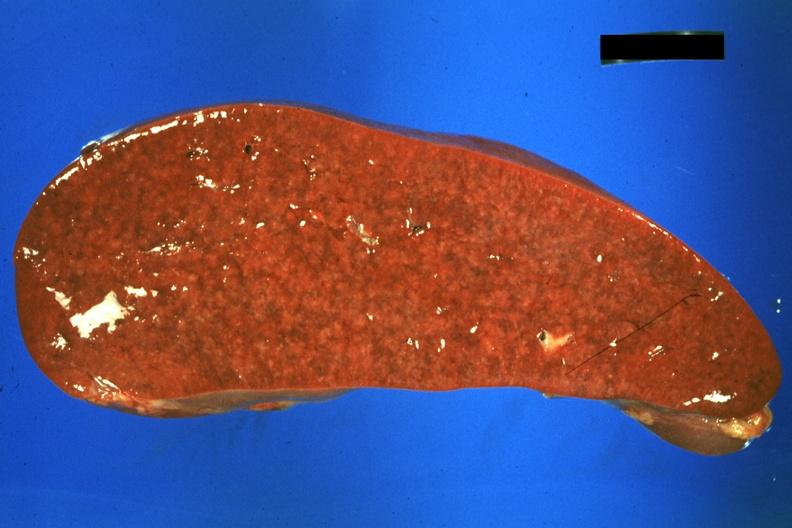does this image show cut surface?
Answer the question using a single word or phrase. Yes 